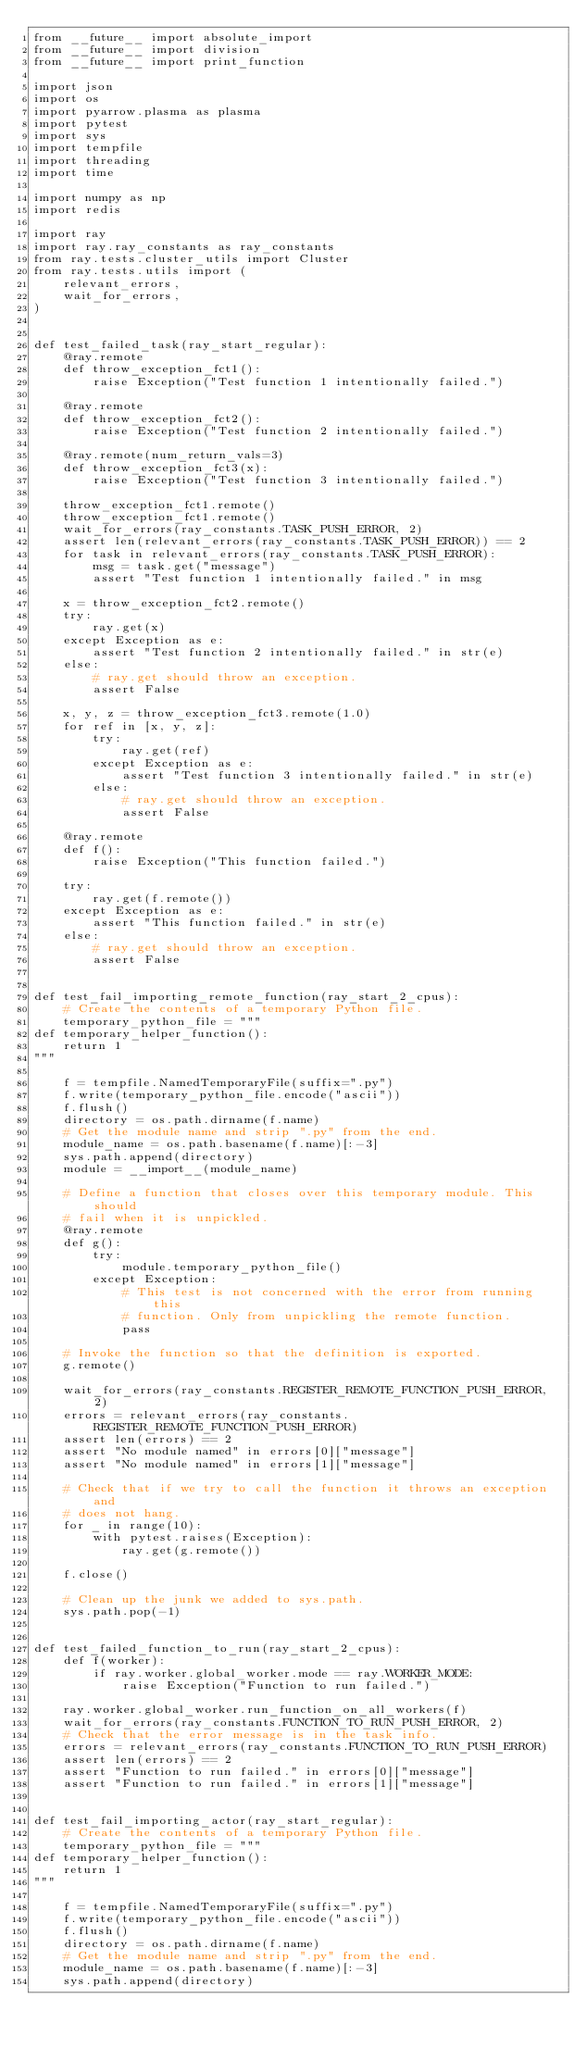<code> <loc_0><loc_0><loc_500><loc_500><_Python_>from __future__ import absolute_import
from __future__ import division
from __future__ import print_function

import json
import os
import pyarrow.plasma as plasma
import pytest
import sys
import tempfile
import threading
import time

import numpy as np
import redis

import ray
import ray.ray_constants as ray_constants
from ray.tests.cluster_utils import Cluster
from ray.tests.utils import (
    relevant_errors,
    wait_for_errors,
)


def test_failed_task(ray_start_regular):
    @ray.remote
    def throw_exception_fct1():
        raise Exception("Test function 1 intentionally failed.")

    @ray.remote
    def throw_exception_fct2():
        raise Exception("Test function 2 intentionally failed.")

    @ray.remote(num_return_vals=3)
    def throw_exception_fct3(x):
        raise Exception("Test function 3 intentionally failed.")

    throw_exception_fct1.remote()
    throw_exception_fct1.remote()
    wait_for_errors(ray_constants.TASK_PUSH_ERROR, 2)
    assert len(relevant_errors(ray_constants.TASK_PUSH_ERROR)) == 2
    for task in relevant_errors(ray_constants.TASK_PUSH_ERROR):
        msg = task.get("message")
        assert "Test function 1 intentionally failed." in msg

    x = throw_exception_fct2.remote()
    try:
        ray.get(x)
    except Exception as e:
        assert "Test function 2 intentionally failed." in str(e)
    else:
        # ray.get should throw an exception.
        assert False

    x, y, z = throw_exception_fct3.remote(1.0)
    for ref in [x, y, z]:
        try:
            ray.get(ref)
        except Exception as e:
            assert "Test function 3 intentionally failed." in str(e)
        else:
            # ray.get should throw an exception.
            assert False

    @ray.remote
    def f():
        raise Exception("This function failed.")

    try:
        ray.get(f.remote())
    except Exception as e:
        assert "This function failed." in str(e)
    else:
        # ray.get should throw an exception.
        assert False


def test_fail_importing_remote_function(ray_start_2_cpus):
    # Create the contents of a temporary Python file.
    temporary_python_file = """
def temporary_helper_function():
    return 1
"""

    f = tempfile.NamedTemporaryFile(suffix=".py")
    f.write(temporary_python_file.encode("ascii"))
    f.flush()
    directory = os.path.dirname(f.name)
    # Get the module name and strip ".py" from the end.
    module_name = os.path.basename(f.name)[:-3]
    sys.path.append(directory)
    module = __import__(module_name)

    # Define a function that closes over this temporary module. This should
    # fail when it is unpickled.
    @ray.remote
    def g():
        try:
            module.temporary_python_file()
        except Exception:
            # This test is not concerned with the error from running this
            # function. Only from unpickling the remote function.
            pass

    # Invoke the function so that the definition is exported.
    g.remote()

    wait_for_errors(ray_constants.REGISTER_REMOTE_FUNCTION_PUSH_ERROR, 2)
    errors = relevant_errors(ray_constants.REGISTER_REMOTE_FUNCTION_PUSH_ERROR)
    assert len(errors) == 2
    assert "No module named" in errors[0]["message"]
    assert "No module named" in errors[1]["message"]

    # Check that if we try to call the function it throws an exception and
    # does not hang.
    for _ in range(10):
        with pytest.raises(Exception):
            ray.get(g.remote())

    f.close()

    # Clean up the junk we added to sys.path.
    sys.path.pop(-1)


def test_failed_function_to_run(ray_start_2_cpus):
    def f(worker):
        if ray.worker.global_worker.mode == ray.WORKER_MODE:
            raise Exception("Function to run failed.")

    ray.worker.global_worker.run_function_on_all_workers(f)
    wait_for_errors(ray_constants.FUNCTION_TO_RUN_PUSH_ERROR, 2)
    # Check that the error message is in the task info.
    errors = relevant_errors(ray_constants.FUNCTION_TO_RUN_PUSH_ERROR)
    assert len(errors) == 2
    assert "Function to run failed." in errors[0]["message"]
    assert "Function to run failed." in errors[1]["message"]


def test_fail_importing_actor(ray_start_regular):
    # Create the contents of a temporary Python file.
    temporary_python_file = """
def temporary_helper_function():
    return 1
"""

    f = tempfile.NamedTemporaryFile(suffix=".py")
    f.write(temporary_python_file.encode("ascii"))
    f.flush()
    directory = os.path.dirname(f.name)
    # Get the module name and strip ".py" from the end.
    module_name = os.path.basename(f.name)[:-3]
    sys.path.append(directory)</code> 